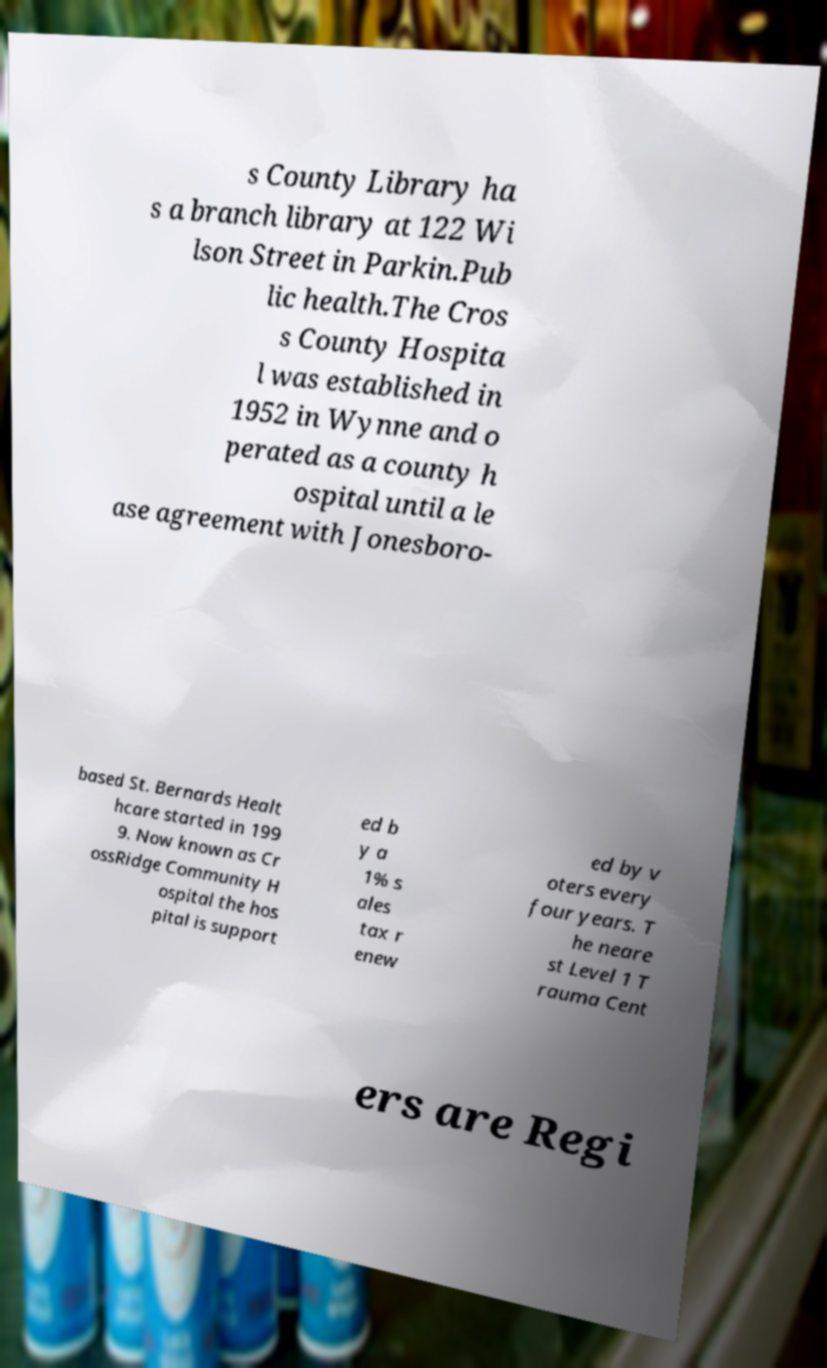For documentation purposes, I need the text within this image transcribed. Could you provide that? s County Library ha s a branch library at 122 Wi lson Street in Parkin.Pub lic health.The Cros s County Hospita l was established in 1952 in Wynne and o perated as a county h ospital until a le ase agreement with Jonesboro- based St. Bernards Healt hcare started in 199 9. Now known as Cr ossRidge Community H ospital the hos pital is support ed b y a 1% s ales tax r enew ed by v oters every four years. T he neare st Level 1 T rauma Cent ers are Regi 